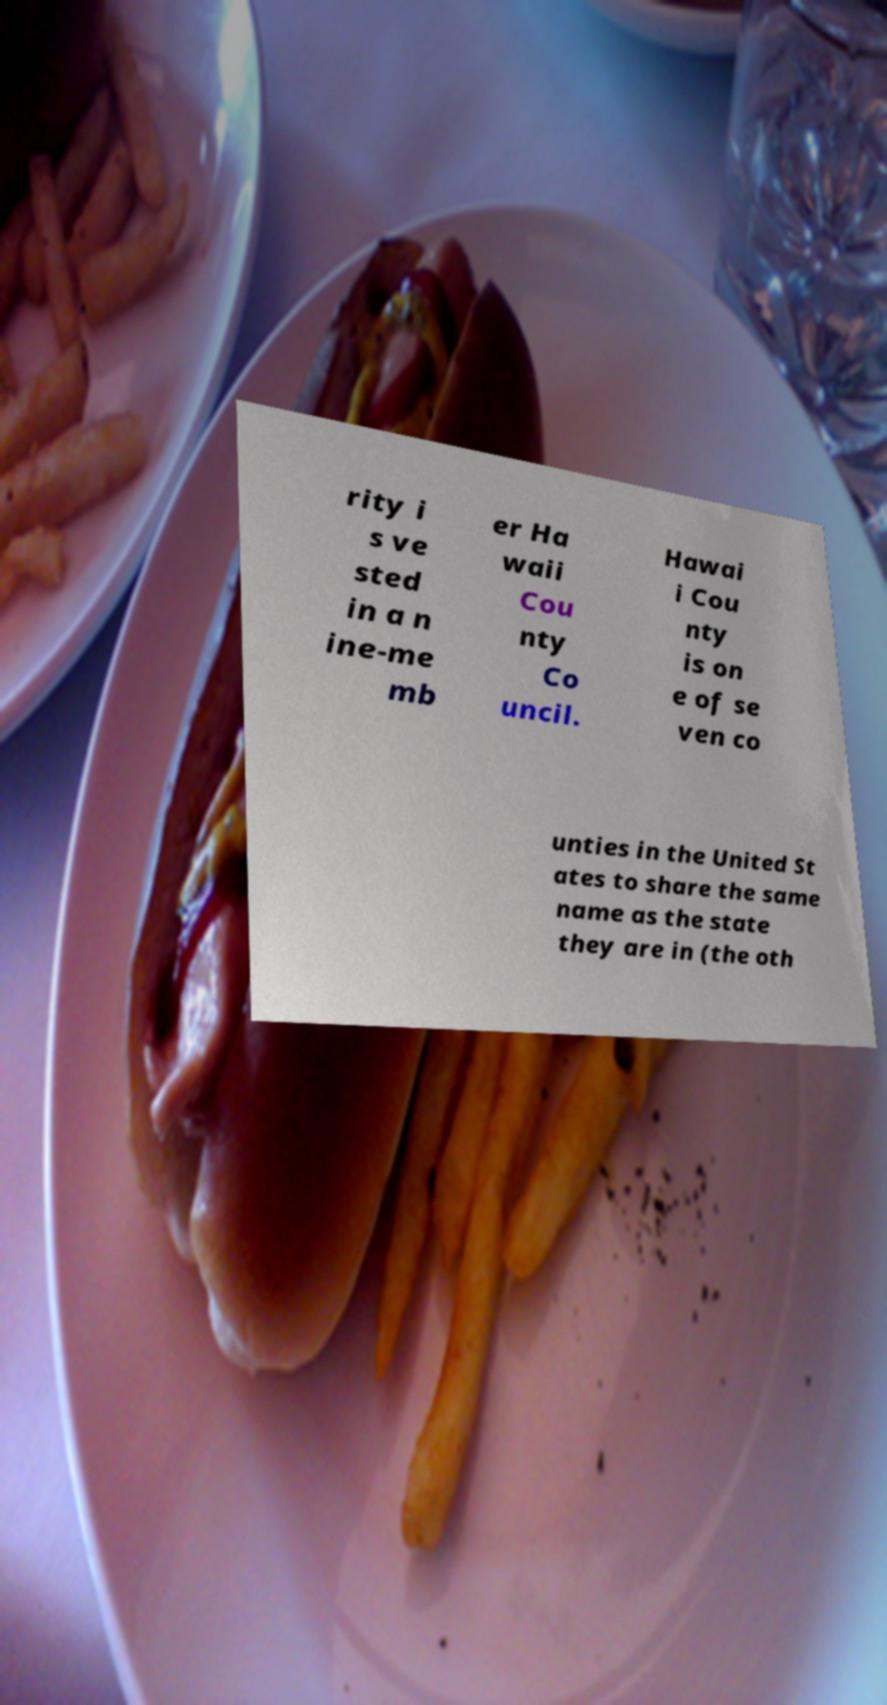Can you accurately transcribe the text from the provided image for me? rity i s ve sted in a n ine-me mb er Ha waii Cou nty Co uncil. Hawai i Cou nty is on e of se ven co unties in the United St ates to share the same name as the state they are in (the oth 